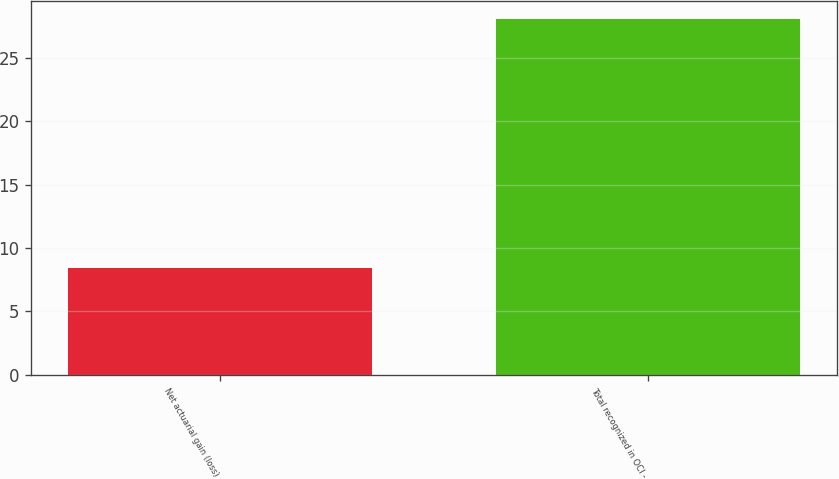<chart> <loc_0><loc_0><loc_500><loc_500><bar_chart><fcel>Net actuarial gain (loss)<fcel>Total recognized in OCI -<nl><fcel>8.4<fcel>28.1<nl></chart> 